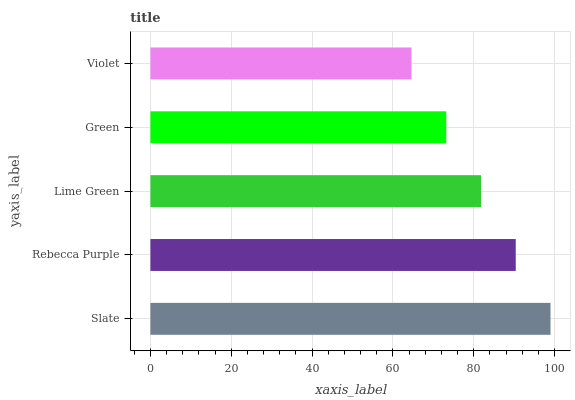Is Violet the minimum?
Answer yes or no. Yes. Is Slate the maximum?
Answer yes or no. Yes. Is Rebecca Purple the minimum?
Answer yes or no. No. Is Rebecca Purple the maximum?
Answer yes or no. No. Is Slate greater than Rebecca Purple?
Answer yes or no. Yes. Is Rebecca Purple less than Slate?
Answer yes or no. Yes. Is Rebecca Purple greater than Slate?
Answer yes or no. No. Is Slate less than Rebecca Purple?
Answer yes or no. No. Is Lime Green the high median?
Answer yes or no. Yes. Is Lime Green the low median?
Answer yes or no. Yes. Is Violet the high median?
Answer yes or no. No. Is Green the low median?
Answer yes or no. No. 